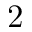<formula> <loc_0><loc_0><loc_500><loc_500>2</formula> 